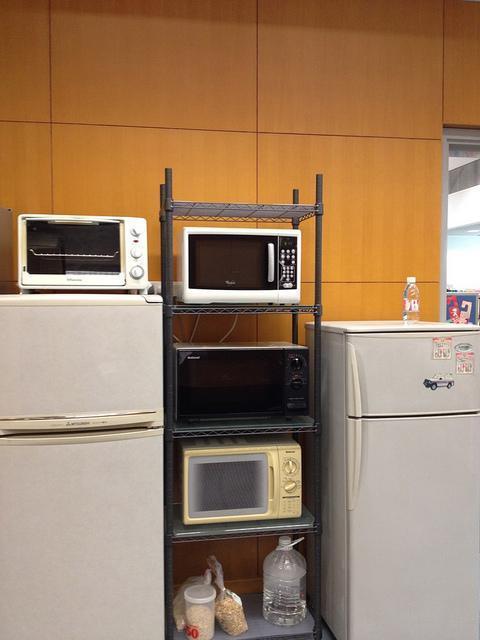How many refrigerators are there?
Give a very brief answer. 2. How many microwaves can be seen?
Give a very brief answer. 4. How many refrigerators can you see?
Give a very brief answer. 2. 